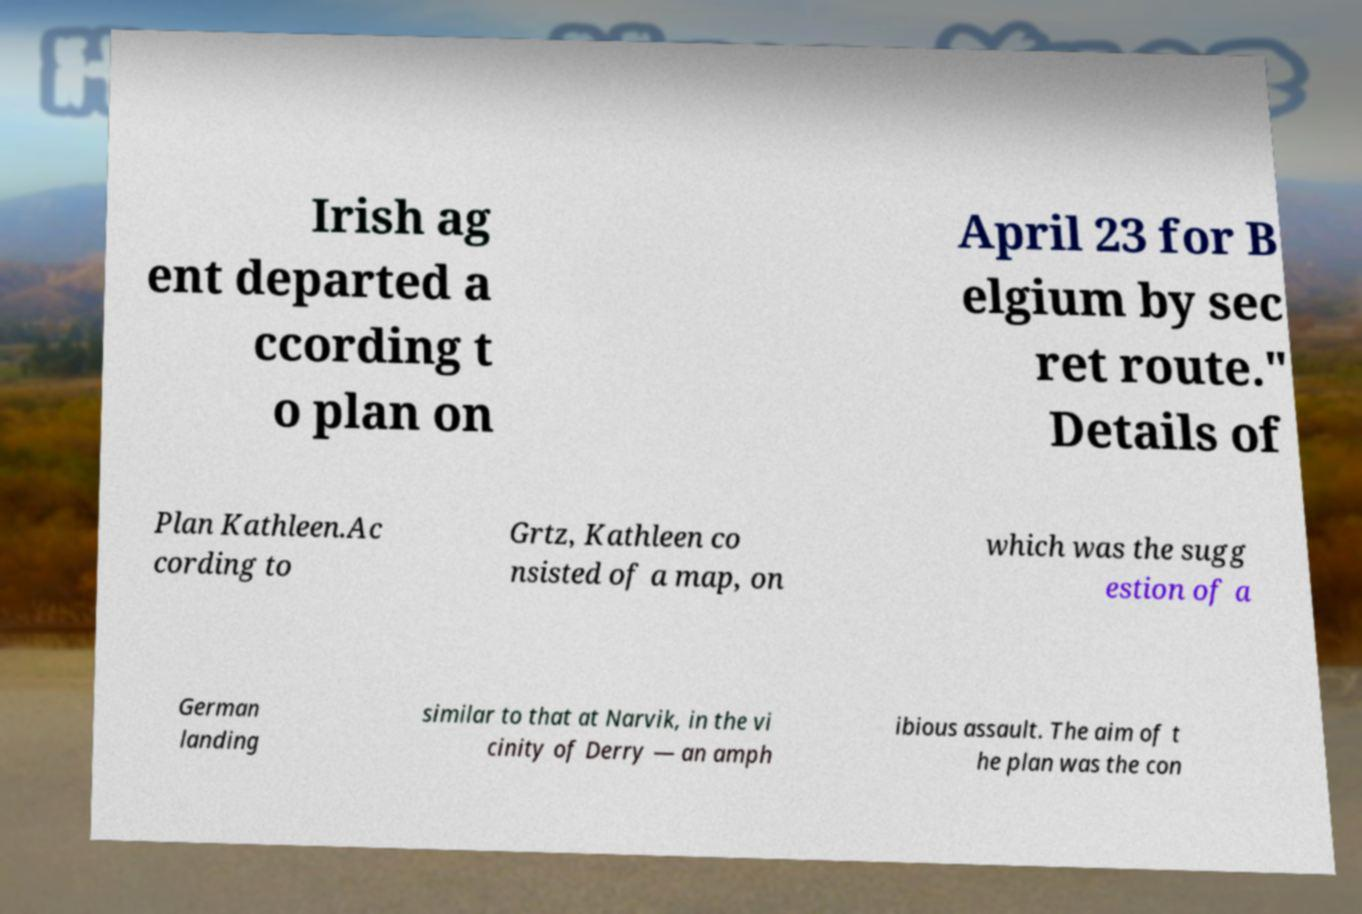For documentation purposes, I need the text within this image transcribed. Could you provide that? Irish ag ent departed a ccording t o plan on April 23 for B elgium by sec ret route." Details of Plan Kathleen.Ac cording to Grtz, Kathleen co nsisted of a map, on which was the sugg estion of a German landing similar to that at Narvik, in the vi cinity of Derry — an amph ibious assault. The aim of t he plan was the con 